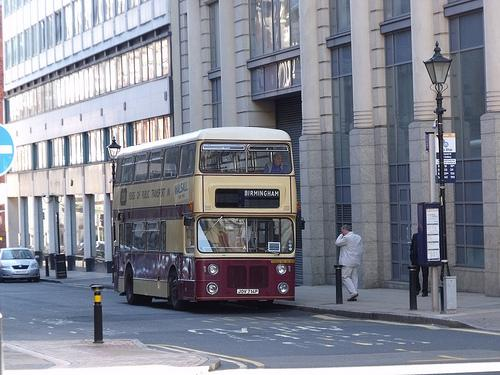Provide a description of the lamppost and any object nearby it. The lamppost is on the street and has a yellow sticker on a nearby pole. Rank the objects in the image based on their size (width x height). 1. The bus - 250x400 cm, 2. The building - 500x300 cm, 3. The car - 180x450 cm, 4. The lamppost - 30x300 cm, 5. The small black pole - 10x100 cm Count the number of windows present in the image. There are 10 windows in the image. Provide a brief description of the key elements in the image. A double-decker bus, people walking on the street, a car, multiple windows on a building, a lamppost, and a few small objects, such as a pole and a sign. What are the detailed descriptions of the two people in the image? One man is wearing a white suit and walking, while another man is riding the bus. What is the color of the car in the image? The car is silver or grey, as both colors are mentioned in the input. Is there any sentiment or emotion conveyed in the image, and if so, what is it? There is no discernible sentiment or emotion conveyed in the image, as it seems to depict a normal, everyday city scene. Identify a few distinguishing features of the bus in the image. The bus is a double-decker, its bottom is red, and it has a black rectangle and a headlamp as part of its features. Explain the characteristics of the windows in the image. The windows are large, long, and grey, located on both the building and the bus. 